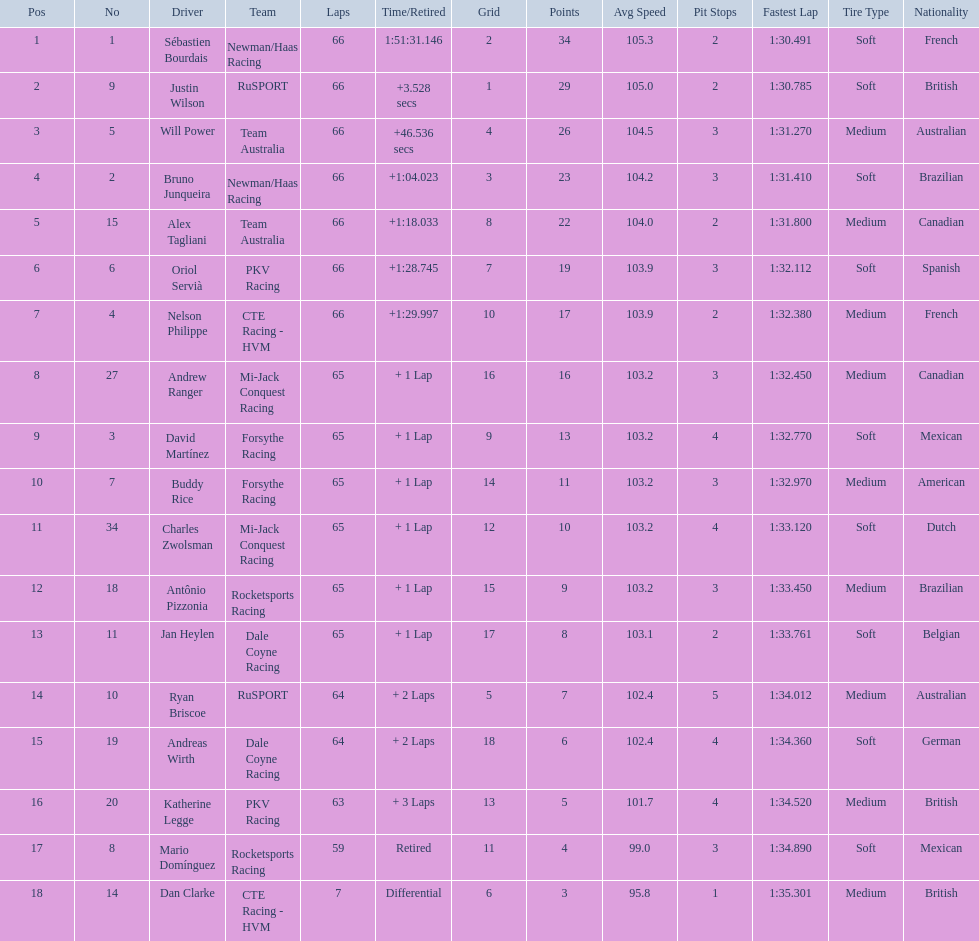Who are all the drivers? Sébastien Bourdais, Justin Wilson, Will Power, Bruno Junqueira, Alex Tagliani, Oriol Servià, Nelson Philippe, Andrew Ranger, David Martínez, Buddy Rice, Charles Zwolsman, Antônio Pizzonia, Jan Heylen, Ryan Briscoe, Andreas Wirth, Katherine Legge, Mario Domínguez, Dan Clarke. What position did they reach? 1, 2, 3, 4, 5, 6, 7, 8, 9, 10, 11, 12, 13, 14, 15, 16, 17, 18. What is the number for each driver? 1, 9, 5, 2, 15, 6, 4, 27, 3, 7, 34, 18, 11, 10, 19, 20, 8, 14. And which player's number and position match? Sébastien Bourdais. 